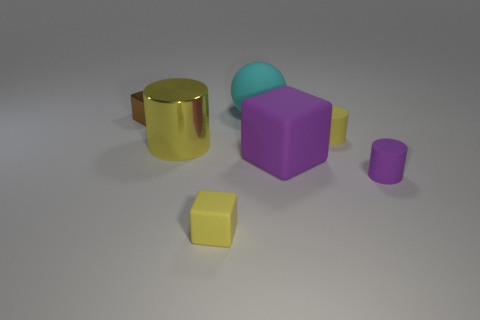Subtract all big matte blocks. How many blocks are left? 2 Subtract all blue blocks. How many yellow cylinders are left? 2 Add 1 large yellow objects. How many objects exist? 8 Subtract 1 cylinders. How many cylinders are left? 2 Subtract all cyan blocks. Subtract all cyan balls. How many blocks are left? 3 Add 6 cyan balls. How many cyan balls are left? 7 Add 7 big cyan balls. How many big cyan balls exist? 8 Subtract 0 cyan blocks. How many objects are left? 7 Subtract all cylinders. How many objects are left? 4 Subtract all small green balls. Subtract all tiny shiny objects. How many objects are left? 6 